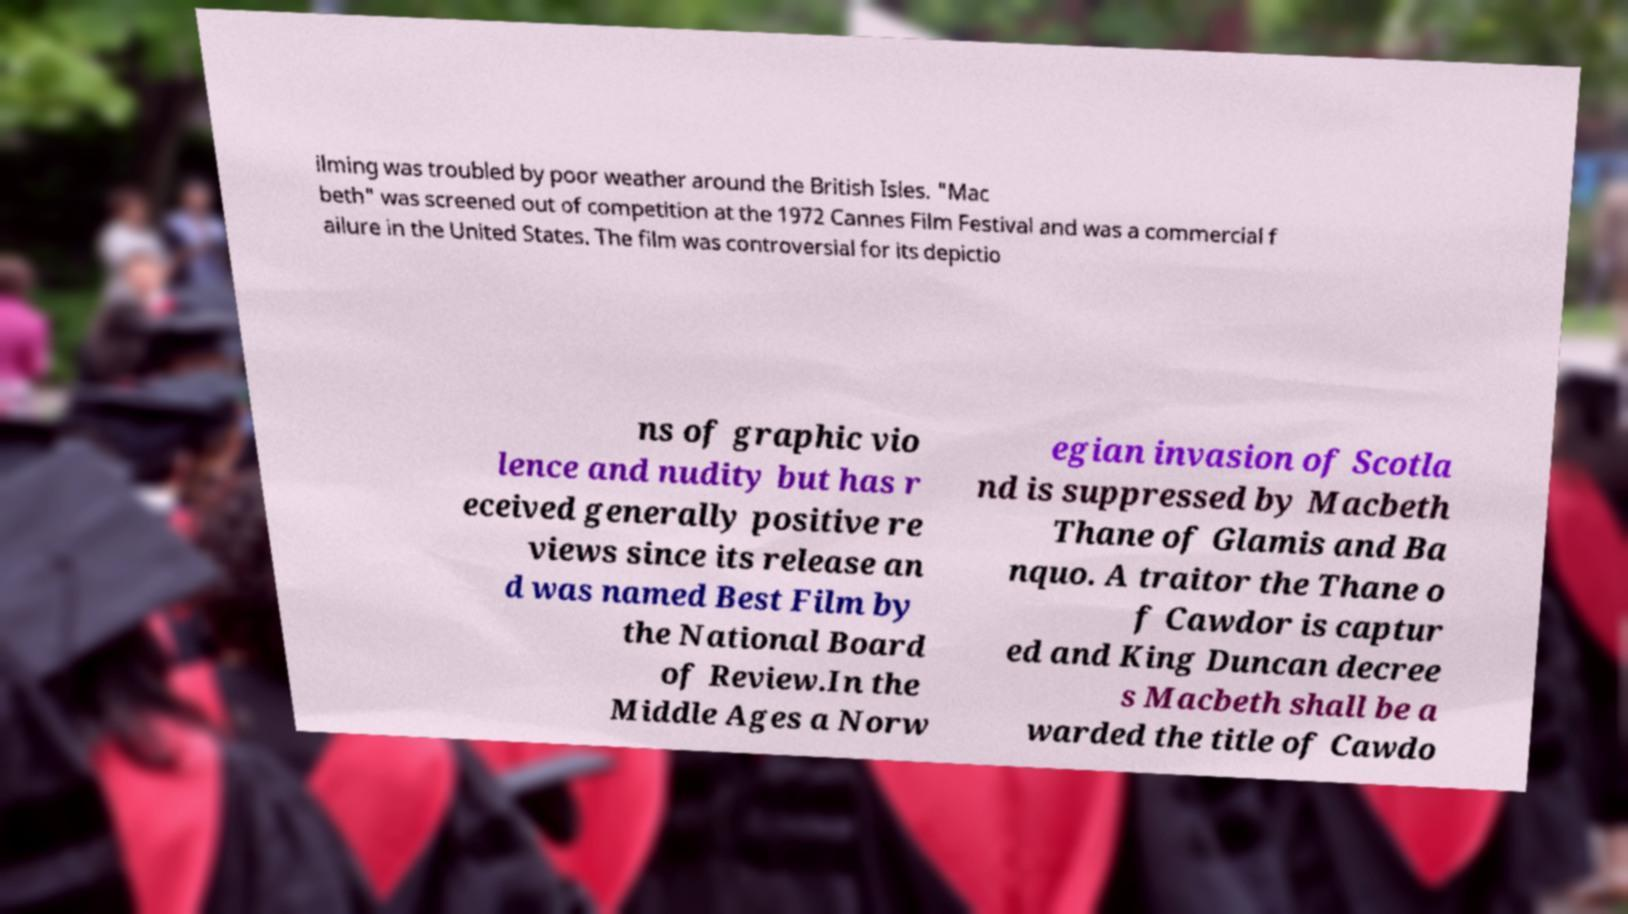For documentation purposes, I need the text within this image transcribed. Could you provide that? ilming was troubled by poor weather around the British Isles. "Mac beth" was screened out of competition at the 1972 Cannes Film Festival and was a commercial f ailure in the United States. The film was controversial for its depictio ns of graphic vio lence and nudity but has r eceived generally positive re views since its release an d was named Best Film by the National Board of Review.In the Middle Ages a Norw egian invasion of Scotla nd is suppressed by Macbeth Thane of Glamis and Ba nquo. A traitor the Thane o f Cawdor is captur ed and King Duncan decree s Macbeth shall be a warded the title of Cawdo 